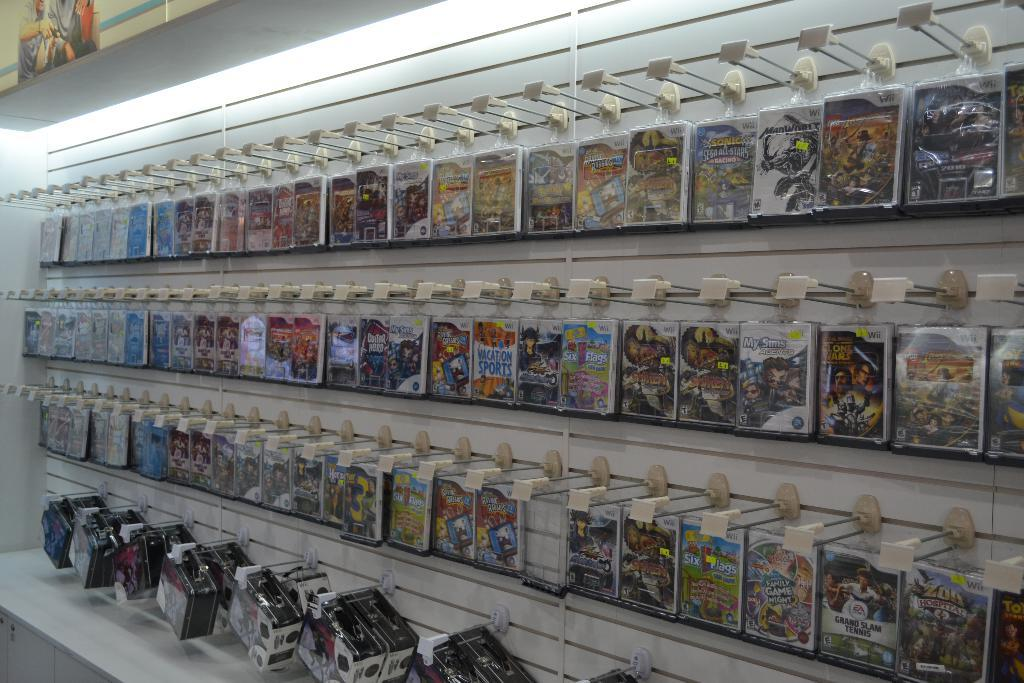Where might the image have been taken? The image might be taken inside a room. What objects can be seen on the right side of the image? There are boxes on the right side of the image. What is the source of light in the image? There is a light at the top of the image. What type of furniture is present at the bottom of the image? There is a table at the bottom of the image. What type of skin can be seen on the goose in the image? There is no goose present in the image, and therefore no skin can be observed. What is the friction between the boxes and the table in the image? The provided facts do not mention any friction between the boxes and the table, so it cannot be determined from the image. 